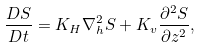<formula> <loc_0><loc_0><loc_500><loc_500>\frac { D S } { D t } = K _ { H } \nabla _ { h } ^ { 2 } S + K _ { v } \frac { \partial ^ { 2 } S } { \partial z ^ { 2 } } ,</formula> 